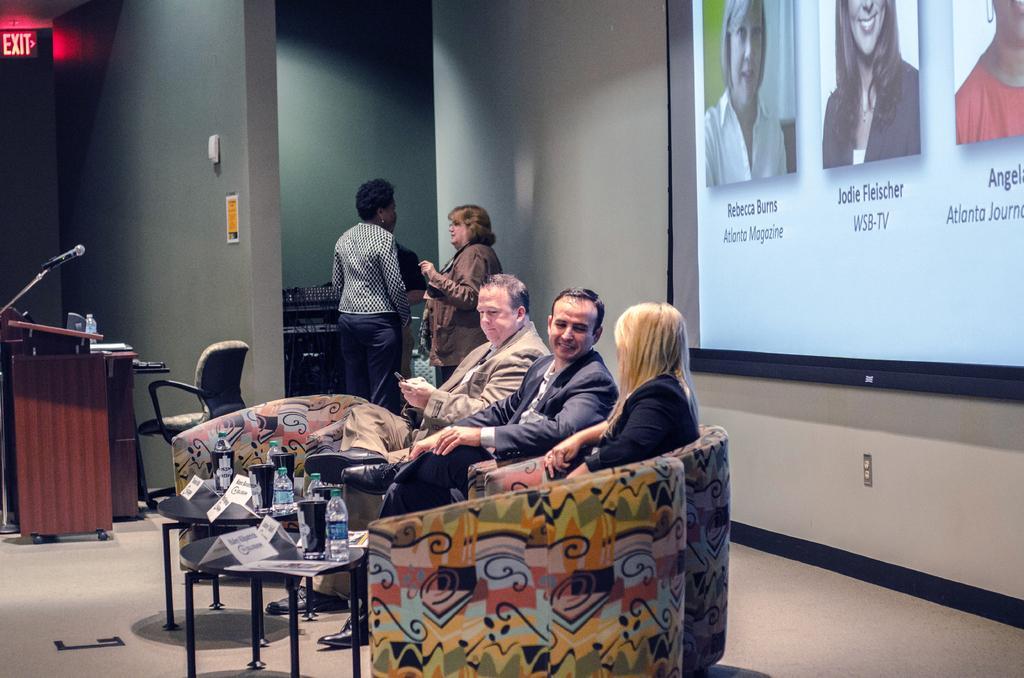Describe this image in one or two sentences. This picture shows a group of people sitting on the chairs and we see water bottles on the table and we see two men standing and we see a projector screen 